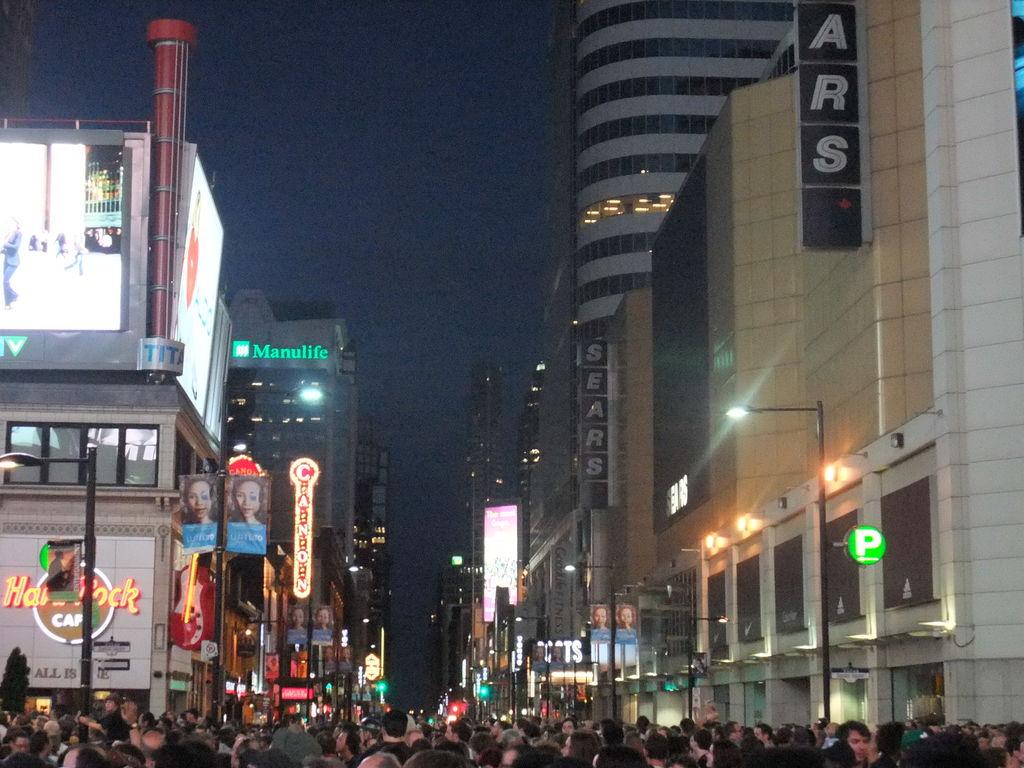What is being advertised on the wall?
Provide a succinct answer. Hardrock cafe. What company owns the building in the background in green letters?
Provide a short and direct response. Manulife. 